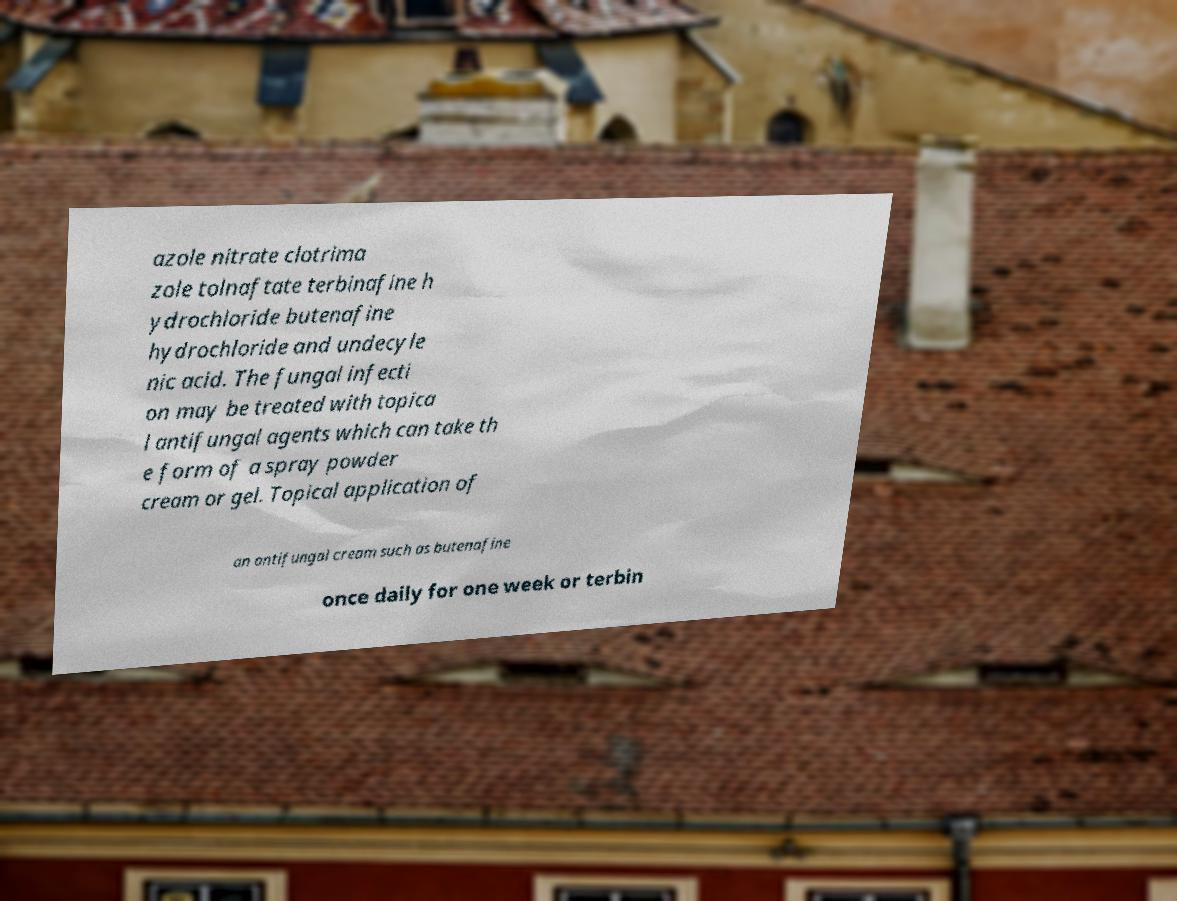Could you assist in decoding the text presented in this image and type it out clearly? azole nitrate clotrima zole tolnaftate terbinafine h ydrochloride butenafine hydrochloride and undecyle nic acid. The fungal infecti on may be treated with topica l antifungal agents which can take th e form of a spray powder cream or gel. Topical application of an antifungal cream such as butenafine once daily for one week or terbin 